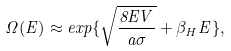Convert formula to latex. <formula><loc_0><loc_0><loc_500><loc_500>\Omega ( E ) \approx e x p \{ \sqrt { \frac { 8 E V } { a \sigma } } + \beta _ { H } E \} ,</formula> 